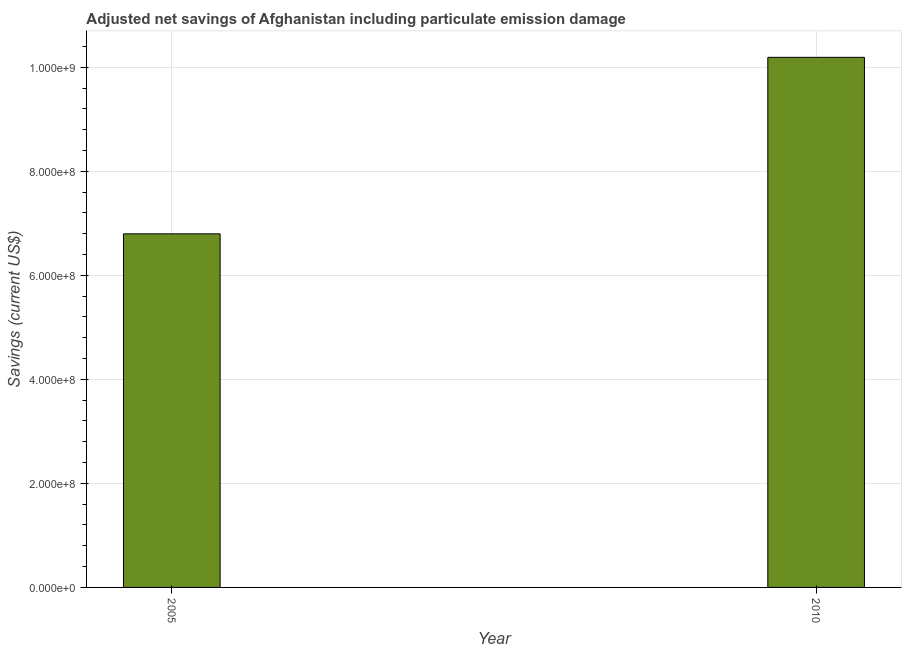Does the graph contain any zero values?
Offer a very short reply. No. What is the title of the graph?
Your answer should be compact. Adjusted net savings of Afghanistan including particulate emission damage. What is the label or title of the X-axis?
Offer a terse response. Year. What is the label or title of the Y-axis?
Your answer should be very brief. Savings (current US$). What is the adjusted net savings in 2005?
Give a very brief answer. 6.80e+08. Across all years, what is the maximum adjusted net savings?
Make the answer very short. 1.02e+09. Across all years, what is the minimum adjusted net savings?
Ensure brevity in your answer.  6.80e+08. In which year was the adjusted net savings maximum?
Offer a terse response. 2010. What is the sum of the adjusted net savings?
Make the answer very short. 1.70e+09. What is the difference between the adjusted net savings in 2005 and 2010?
Ensure brevity in your answer.  -3.39e+08. What is the average adjusted net savings per year?
Your response must be concise. 8.49e+08. What is the median adjusted net savings?
Make the answer very short. 8.49e+08. What is the ratio of the adjusted net savings in 2005 to that in 2010?
Your response must be concise. 0.67. In how many years, is the adjusted net savings greater than the average adjusted net savings taken over all years?
Keep it short and to the point. 1. Are all the bars in the graph horizontal?
Provide a succinct answer. No. How many years are there in the graph?
Make the answer very short. 2. Are the values on the major ticks of Y-axis written in scientific E-notation?
Your answer should be compact. Yes. What is the Savings (current US$) in 2005?
Provide a short and direct response. 6.80e+08. What is the Savings (current US$) in 2010?
Your answer should be very brief. 1.02e+09. What is the difference between the Savings (current US$) in 2005 and 2010?
Provide a succinct answer. -3.39e+08. What is the ratio of the Savings (current US$) in 2005 to that in 2010?
Ensure brevity in your answer.  0.67. 